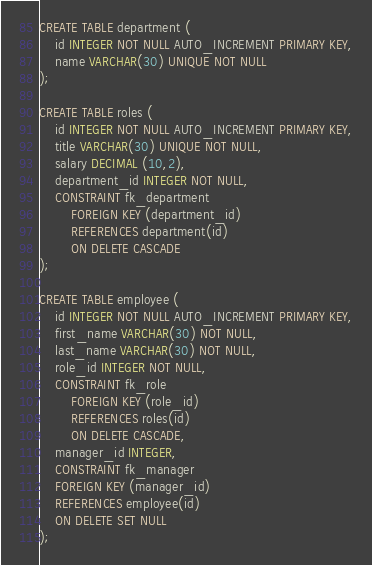<code> <loc_0><loc_0><loc_500><loc_500><_SQL_>CREATE TABLE department (
    id INTEGER NOT NULL AUTO_INCREMENT PRIMARY KEY,
    name VARCHAR(30) UNIQUE NOT NULL
);

CREATE TABLE roles (
    id INTEGER NOT NULL AUTO_INCREMENT PRIMARY KEY,
    title VARCHAR(30) UNIQUE NOT NULL,
    salary DECIMAL (10,2),
    department_id INTEGER NOT NULL,
    CONSTRAINT fk_department
        FOREIGN KEY (department_id)
        REFERENCES department(id)
        ON DELETE CASCADE
);

CREATE TABLE employee (
    id INTEGER NOT NULL AUTO_INCREMENT PRIMARY KEY,
    first_name VARCHAR(30) NOT NULL,
    last_name VARCHAR(30) NOT NULL,
    role_id INTEGER NOT NULL,
    CONSTRAINT fk_role
        FOREIGN KEY (role_id)
        REFERENCES roles(id)
        ON DELETE CASCADE,
    manager_id INTEGER,
    CONSTRAINT fk_manager
    FOREIGN KEY (manager_id)
    REFERENCES employee(id)
    ON DELETE SET NULL
);</code> 